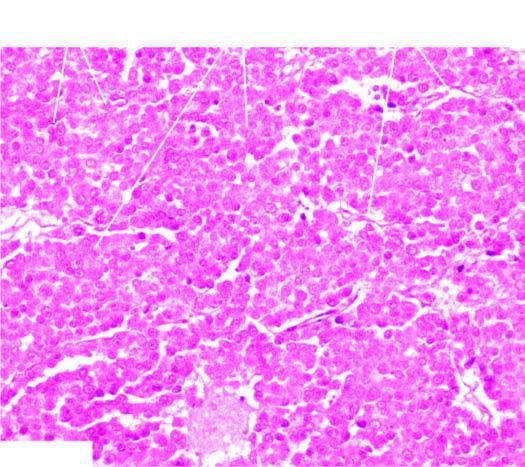what are separated by scanty fibrous stroma that is infiltrated by lymphocytes?
Answer the question using a single word or phrase. Masses of large uniform tumour cells 